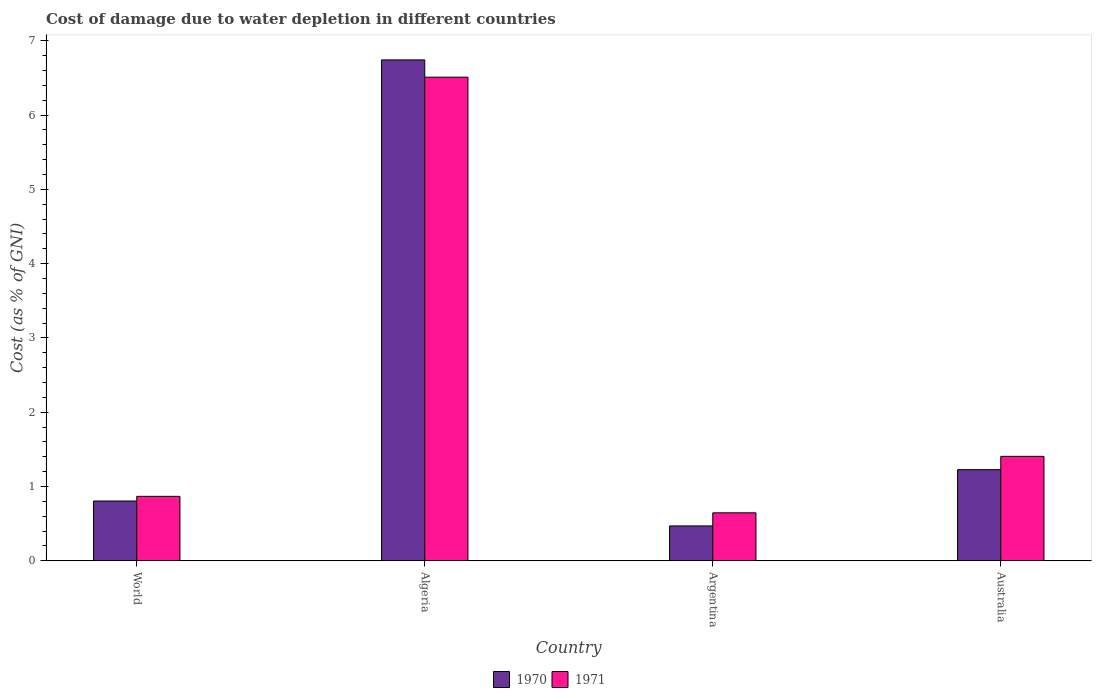How many different coloured bars are there?
Provide a succinct answer. 2. Are the number of bars per tick equal to the number of legend labels?
Keep it short and to the point. Yes. What is the label of the 3rd group of bars from the left?
Offer a very short reply. Argentina. What is the cost of damage caused due to water depletion in 1971 in Argentina?
Offer a terse response. 0.65. Across all countries, what is the maximum cost of damage caused due to water depletion in 1970?
Offer a terse response. 6.74. Across all countries, what is the minimum cost of damage caused due to water depletion in 1970?
Make the answer very short. 0.47. In which country was the cost of damage caused due to water depletion in 1970 maximum?
Make the answer very short. Algeria. In which country was the cost of damage caused due to water depletion in 1970 minimum?
Provide a short and direct response. Argentina. What is the total cost of damage caused due to water depletion in 1970 in the graph?
Ensure brevity in your answer.  9.24. What is the difference between the cost of damage caused due to water depletion in 1970 in Australia and that in World?
Keep it short and to the point. 0.42. What is the difference between the cost of damage caused due to water depletion in 1970 in Australia and the cost of damage caused due to water depletion in 1971 in Argentina?
Offer a terse response. 0.58. What is the average cost of damage caused due to water depletion in 1971 per country?
Your answer should be very brief. 2.36. What is the difference between the cost of damage caused due to water depletion of/in 1971 and cost of damage caused due to water depletion of/in 1970 in Algeria?
Keep it short and to the point. -0.23. What is the ratio of the cost of damage caused due to water depletion in 1971 in Algeria to that in Australia?
Your response must be concise. 4.63. What is the difference between the highest and the second highest cost of damage caused due to water depletion in 1971?
Ensure brevity in your answer.  -0.54. What is the difference between the highest and the lowest cost of damage caused due to water depletion in 1970?
Offer a terse response. 6.27. What does the 2nd bar from the left in Argentina represents?
Provide a succinct answer. 1971. What does the 2nd bar from the right in World represents?
Offer a terse response. 1970. How many bars are there?
Offer a very short reply. 8. How many countries are there in the graph?
Your answer should be compact. 4. Does the graph contain any zero values?
Provide a short and direct response. No. How are the legend labels stacked?
Keep it short and to the point. Horizontal. What is the title of the graph?
Offer a very short reply. Cost of damage due to water depletion in different countries. Does "1977" appear as one of the legend labels in the graph?
Make the answer very short. No. What is the label or title of the X-axis?
Provide a succinct answer. Country. What is the label or title of the Y-axis?
Offer a terse response. Cost (as % of GNI). What is the Cost (as % of GNI) in 1970 in World?
Your answer should be compact. 0.8. What is the Cost (as % of GNI) of 1971 in World?
Give a very brief answer. 0.87. What is the Cost (as % of GNI) in 1970 in Algeria?
Make the answer very short. 6.74. What is the Cost (as % of GNI) of 1971 in Algeria?
Offer a very short reply. 6.51. What is the Cost (as % of GNI) in 1970 in Argentina?
Ensure brevity in your answer.  0.47. What is the Cost (as % of GNI) of 1971 in Argentina?
Your response must be concise. 0.65. What is the Cost (as % of GNI) of 1970 in Australia?
Offer a terse response. 1.23. What is the Cost (as % of GNI) in 1971 in Australia?
Ensure brevity in your answer.  1.41. Across all countries, what is the maximum Cost (as % of GNI) of 1970?
Give a very brief answer. 6.74. Across all countries, what is the maximum Cost (as % of GNI) in 1971?
Keep it short and to the point. 6.51. Across all countries, what is the minimum Cost (as % of GNI) in 1970?
Give a very brief answer. 0.47. Across all countries, what is the minimum Cost (as % of GNI) of 1971?
Your answer should be very brief. 0.65. What is the total Cost (as % of GNI) in 1970 in the graph?
Your answer should be very brief. 9.24. What is the total Cost (as % of GNI) in 1971 in the graph?
Offer a very short reply. 9.43. What is the difference between the Cost (as % of GNI) of 1970 in World and that in Algeria?
Provide a succinct answer. -5.94. What is the difference between the Cost (as % of GNI) in 1971 in World and that in Algeria?
Provide a succinct answer. -5.64. What is the difference between the Cost (as % of GNI) of 1970 in World and that in Argentina?
Your answer should be very brief. 0.34. What is the difference between the Cost (as % of GNI) of 1971 in World and that in Argentina?
Your response must be concise. 0.22. What is the difference between the Cost (as % of GNI) of 1970 in World and that in Australia?
Provide a short and direct response. -0.42. What is the difference between the Cost (as % of GNI) of 1971 in World and that in Australia?
Give a very brief answer. -0.54. What is the difference between the Cost (as % of GNI) of 1970 in Algeria and that in Argentina?
Your answer should be very brief. 6.27. What is the difference between the Cost (as % of GNI) of 1971 in Algeria and that in Argentina?
Your response must be concise. 5.86. What is the difference between the Cost (as % of GNI) of 1970 in Algeria and that in Australia?
Your answer should be compact. 5.52. What is the difference between the Cost (as % of GNI) in 1971 in Algeria and that in Australia?
Your answer should be very brief. 5.1. What is the difference between the Cost (as % of GNI) of 1970 in Argentina and that in Australia?
Your response must be concise. -0.76. What is the difference between the Cost (as % of GNI) of 1971 in Argentina and that in Australia?
Offer a terse response. -0.76. What is the difference between the Cost (as % of GNI) in 1970 in World and the Cost (as % of GNI) in 1971 in Algeria?
Provide a short and direct response. -5.71. What is the difference between the Cost (as % of GNI) of 1970 in World and the Cost (as % of GNI) of 1971 in Argentina?
Make the answer very short. 0.16. What is the difference between the Cost (as % of GNI) in 1970 in World and the Cost (as % of GNI) in 1971 in Australia?
Your answer should be compact. -0.6. What is the difference between the Cost (as % of GNI) in 1970 in Algeria and the Cost (as % of GNI) in 1971 in Argentina?
Give a very brief answer. 6.1. What is the difference between the Cost (as % of GNI) of 1970 in Algeria and the Cost (as % of GNI) of 1971 in Australia?
Your response must be concise. 5.34. What is the difference between the Cost (as % of GNI) of 1970 in Argentina and the Cost (as % of GNI) of 1971 in Australia?
Your answer should be very brief. -0.94. What is the average Cost (as % of GNI) in 1970 per country?
Your answer should be very brief. 2.31. What is the average Cost (as % of GNI) of 1971 per country?
Keep it short and to the point. 2.36. What is the difference between the Cost (as % of GNI) in 1970 and Cost (as % of GNI) in 1971 in World?
Keep it short and to the point. -0.06. What is the difference between the Cost (as % of GNI) in 1970 and Cost (as % of GNI) in 1971 in Algeria?
Provide a succinct answer. 0.23. What is the difference between the Cost (as % of GNI) of 1970 and Cost (as % of GNI) of 1971 in Argentina?
Your response must be concise. -0.18. What is the difference between the Cost (as % of GNI) of 1970 and Cost (as % of GNI) of 1971 in Australia?
Ensure brevity in your answer.  -0.18. What is the ratio of the Cost (as % of GNI) of 1970 in World to that in Algeria?
Provide a succinct answer. 0.12. What is the ratio of the Cost (as % of GNI) of 1971 in World to that in Algeria?
Offer a terse response. 0.13. What is the ratio of the Cost (as % of GNI) of 1970 in World to that in Argentina?
Give a very brief answer. 1.72. What is the ratio of the Cost (as % of GNI) in 1971 in World to that in Argentina?
Provide a short and direct response. 1.34. What is the ratio of the Cost (as % of GNI) of 1970 in World to that in Australia?
Your answer should be very brief. 0.66. What is the ratio of the Cost (as % of GNI) of 1971 in World to that in Australia?
Your response must be concise. 0.62. What is the ratio of the Cost (as % of GNI) of 1970 in Algeria to that in Argentina?
Provide a succinct answer. 14.38. What is the ratio of the Cost (as % of GNI) of 1971 in Algeria to that in Argentina?
Offer a very short reply. 10.08. What is the ratio of the Cost (as % of GNI) in 1970 in Algeria to that in Australia?
Your answer should be very brief. 5.5. What is the ratio of the Cost (as % of GNI) in 1971 in Algeria to that in Australia?
Your answer should be very brief. 4.63. What is the ratio of the Cost (as % of GNI) in 1970 in Argentina to that in Australia?
Offer a very short reply. 0.38. What is the ratio of the Cost (as % of GNI) of 1971 in Argentina to that in Australia?
Your answer should be very brief. 0.46. What is the difference between the highest and the second highest Cost (as % of GNI) in 1970?
Offer a terse response. 5.52. What is the difference between the highest and the second highest Cost (as % of GNI) in 1971?
Offer a terse response. 5.1. What is the difference between the highest and the lowest Cost (as % of GNI) of 1970?
Provide a succinct answer. 6.27. What is the difference between the highest and the lowest Cost (as % of GNI) in 1971?
Your answer should be compact. 5.86. 